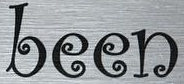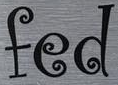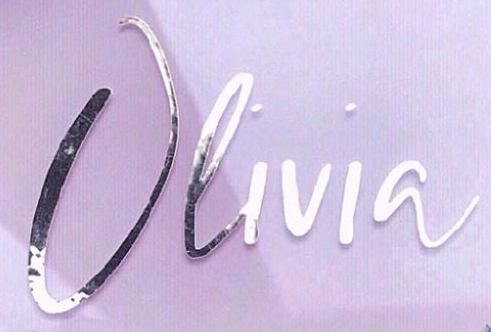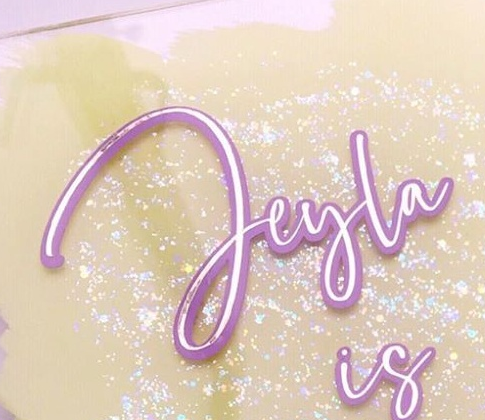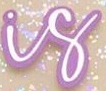What words can you see in these images in sequence, separated by a semicolon? been; fed; Olivia; Jeyla; is 